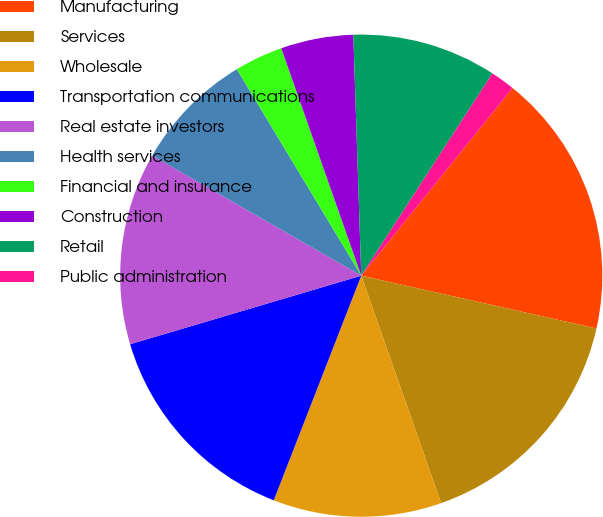Convert chart. <chart><loc_0><loc_0><loc_500><loc_500><pie_chart><fcel>Manufacturing<fcel>Services<fcel>Wholesale<fcel>Transportation communications<fcel>Real estate investors<fcel>Health services<fcel>Financial and insurance<fcel>Construction<fcel>Retail<fcel>Public administration<nl><fcel>17.72%<fcel>16.11%<fcel>11.29%<fcel>14.5%<fcel>12.89%<fcel>8.07%<fcel>3.25%<fcel>4.86%<fcel>9.68%<fcel>1.64%<nl></chart> 